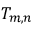<formula> <loc_0><loc_0><loc_500><loc_500>T _ { m , n }</formula> 